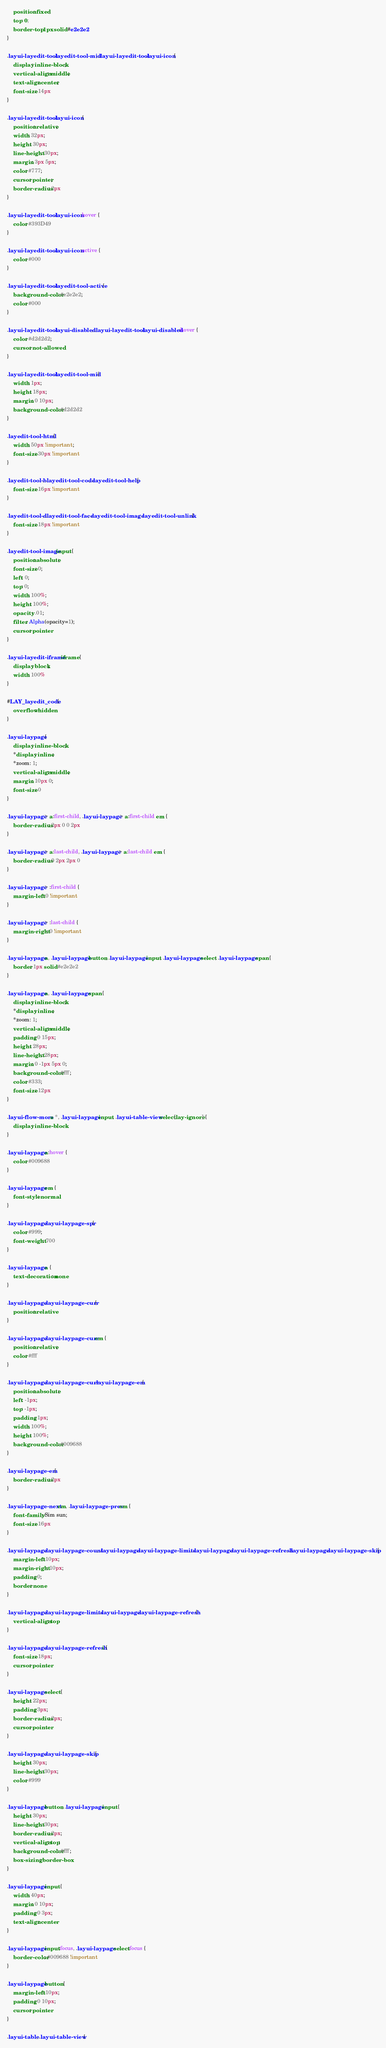Convert code to text. <code><loc_0><loc_0><loc_500><loc_500><_CSS_>    position: fixed;
    top: 0;
    border-top: 1px solid #e2e2e2
}

.layui-layedit-tool .layedit-tool-mid, .layui-layedit-tool .layui-icon {
    display: inline-block;
    vertical-align: middle;
    text-align: center;
    font-size: 14px
}

.layui-layedit-tool .layui-icon {
    position: relative;
    width: 32px;
    height: 30px;
    line-height: 30px;
    margin: 3px 5px;
    color: #777;
    cursor: pointer;
    border-radius: 2px
}

.layui-layedit-tool .layui-icon:hover {
    color: #393D49
}

.layui-layedit-tool .layui-icon:active {
    color: #000
}

.layui-layedit-tool .layedit-tool-active {
    background-color: #e2e2e2;
    color: #000
}

.layui-layedit-tool .layui-disabled, .layui-layedit-tool .layui-disabled:hover {
    color: #d2d2d2;
    cursor: not-allowed
}

.layui-layedit-tool .layedit-tool-mid {
    width: 1px;
    height: 18px;
    margin: 0 10px;
    background-color: #d2d2d2
}

.layedit-tool-html {
    width: 50px !important;
    font-size: 30px !important
}

.layedit-tool-b, .layedit-tool-code, .layedit-tool-help {
    font-size: 16px !important
}

.layedit-tool-d, .layedit-tool-face, .layedit-tool-image, .layedit-tool-unlink {
    font-size: 18px !important
}

.layedit-tool-image input {
    position: absolute;
    font-size: 0;
    left: 0;
    top: 0;
    width: 100%;
    height: 100%;
    opacity: .01;
    filter: Alpha(opacity=1);
    cursor: pointer
}

.layui-layedit-iframe iframe {
    display: block;
    width: 100%
}

#LAY_layedit_code {
    overflow: hidden
}

.layui-laypage {
    display: inline-block;
    *display: inline;
    *zoom: 1;
    vertical-align: middle;
    margin: 10px 0;
    font-size: 0
}

.layui-laypage > a:first-child, .layui-laypage > a:first-child em {
    border-radius: 2px 0 0 2px
}

.layui-laypage > a:last-child, .layui-laypage > a:last-child em {
    border-radius: 0 2px 2px 0
}

.layui-laypage > :first-child {
    margin-left: 0 !important
}

.layui-laypage > :last-child {
    margin-right: 0 !important
}

.layui-laypage a, .layui-laypage button, .layui-laypage input, .layui-laypage select, .layui-laypage span {
    border: 1px solid #e2e2e2
}

.layui-laypage a, .layui-laypage span {
    display: inline-block;
    *display: inline;
    *zoom: 1;
    vertical-align: middle;
    padding: 0 15px;
    height: 28px;
    line-height: 28px;
    margin: 0 -1px 5px 0;
    background-color: #fff;
    color: #333;
    font-size: 12px
}

.layui-flow-more a *, .layui-laypage input, .layui-table-view select[lay-ignore] {
    display: inline-block
}

.layui-laypage a:hover {
    color: #009688
}

.layui-laypage em {
    font-style: normal
}

.layui-laypage .layui-laypage-spr {
    color: #999;
    font-weight: 700
}

.layui-laypage a {
    text-decoration: none
}

.layui-laypage .layui-laypage-curr {
    position: relative
}

.layui-laypage .layui-laypage-curr em {
    position: relative;
    color: #fff
}

.layui-laypage .layui-laypage-curr .layui-laypage-em {
    position: absolute;
    left: -1px;
    top: -1px;
    padding: 1px;
    width: 100%;
    height: 100%;
    background-color: #009688
}

.layui-laypage-em {
    border-radius: 2px
}

.layui-laypage-next em, .layui-laypage-prev em {
    font-family: Sim sun;
    font-size: 16px
}

.layui-laypage .layui-laypage-count, .layui-laypage .layui-laypage-limits, .layui-laypage .layui-laypage-refresh, .layui-laypage .layui-laypage-skip {
    margin-left: 10px;
    margin-right: 10px;
    padding: 0;
    border: none
}

.layui-laypage .layui-laypage-limits, .layui-laypage .layui-laypage-refresh {
    vertical-align: top
}

.layui-laypage .layui-laypage-refresh i {
    font-size: 18px;
    cursor: pointer
}

.layui-laypage select {
    height: 22px;
    padding: 3px;
    border-radius: 2px;
    cursor: pointer
}

.layui-laypage .layui-laypage-skip {
    height: 30px;
    line-height: 30px;
    color: #999
}

.layui-laypage button, .layui-laypage input {
    height: 30px;
    line-height: 30px;
    border-radius: 2px;
    vertical-align: top;
    background-color: #fff;
    box-sizing: border-box
}

.layui-laypage input {
    width: 40px;
    margin: 0 10px;
    padding: 0 3px;
    text-align: center
}

.layui-laypage input:focus, .layui-laypage select:focus {
    border-color: #009688 !important
}

.layui-laypage button {
    margin-left: 10px;
    padding: 0 10px;
    cursor: pointer
}

.layui-table, .layui-table-view {</code> 